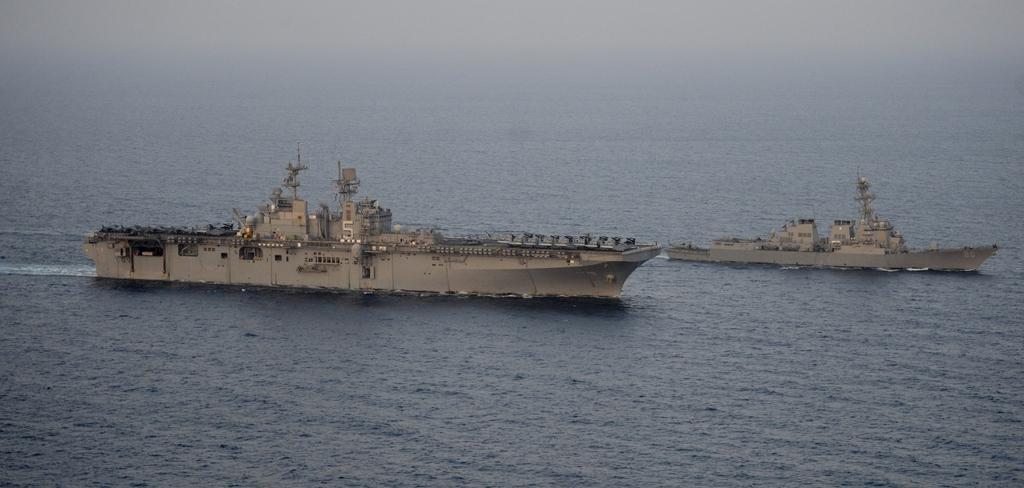Could you give a brief overview of what you see in this image? In this picture we can see there are ships on the water. 